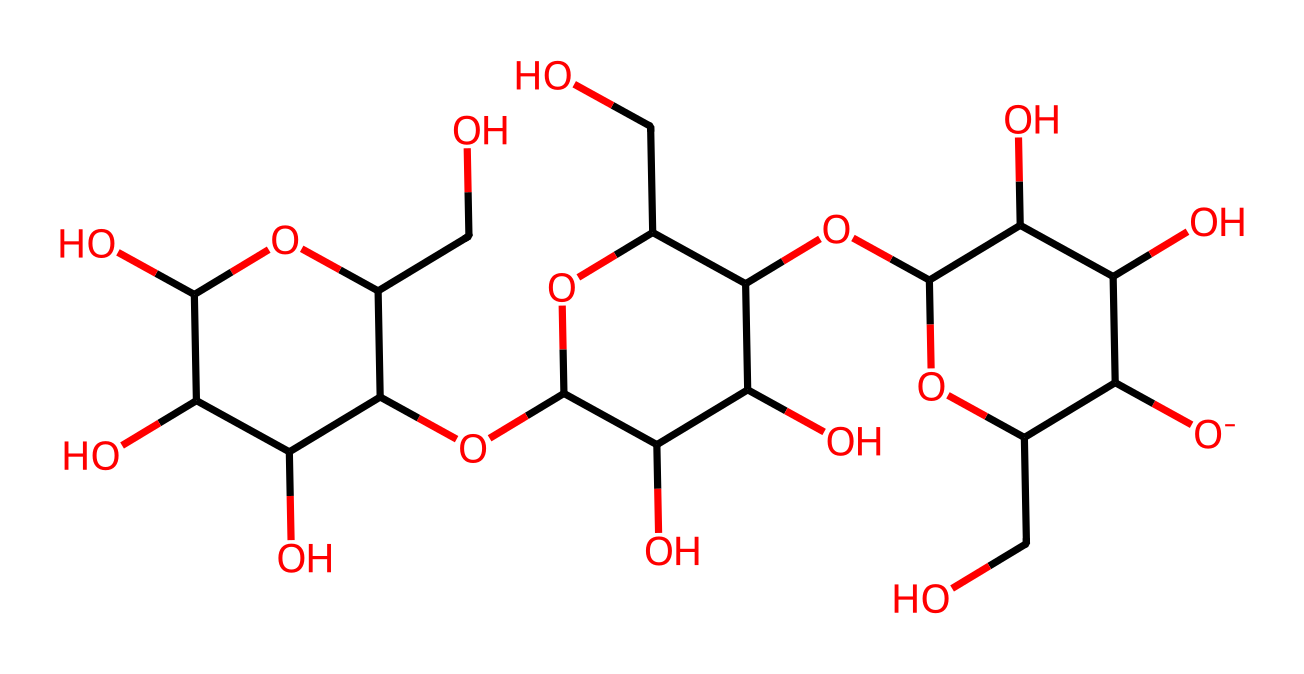What is the main type of polymer represented in this structure? The structure features a recurring unit known as glucose, which indicates it is a polysaccharide, commonly known as cellulose. Cellulose consists exclusively of glucose monomers linked together.
Answer: polysaccharide How many carbon atoms are in the structure? By counting the number of carbon (C) atoms represented in the SMILES string, we can determine there are 6 carbon rings that represent glucose units. Each glucose unit contributes 6 carbon atoms. In total, there are 6 glucose units, hence 6 x 6 = 36 carbon atoms.
Answer: 36 What functional groups are present in this structure? The SMILES representation shows hydroxyl (-OH) groups throughout the structure, which indicates that this polysaccharide is highly hydrophilic, contributing to the solubility and interaction of cellulose with water.
Answer: hydroxyl groups What type of linkage is primarily found in cellulose? In cellulose, the glucose units are connected by β-1,4-glycosidic bonds. The β indicates the orientation of the glycosidic bond that connects these units.
Answer: β-1,4-glycosidic bonds How many oxygen atoms can be found in the structure? By identifying the number of oxygen (O) atoms in the SMILES representation, we find there are 10 oxygen atoms present, which mostly from hydroxyl groups and ether linkages between the glucose units.
Answer: 10 What is the degree of polymerization in this cellulose structure? The degree of polymerization defines the number of glucose units in the polymer. Since there are six glucose units in this structure, its degree of polymerization is 6.
Answer: 6 